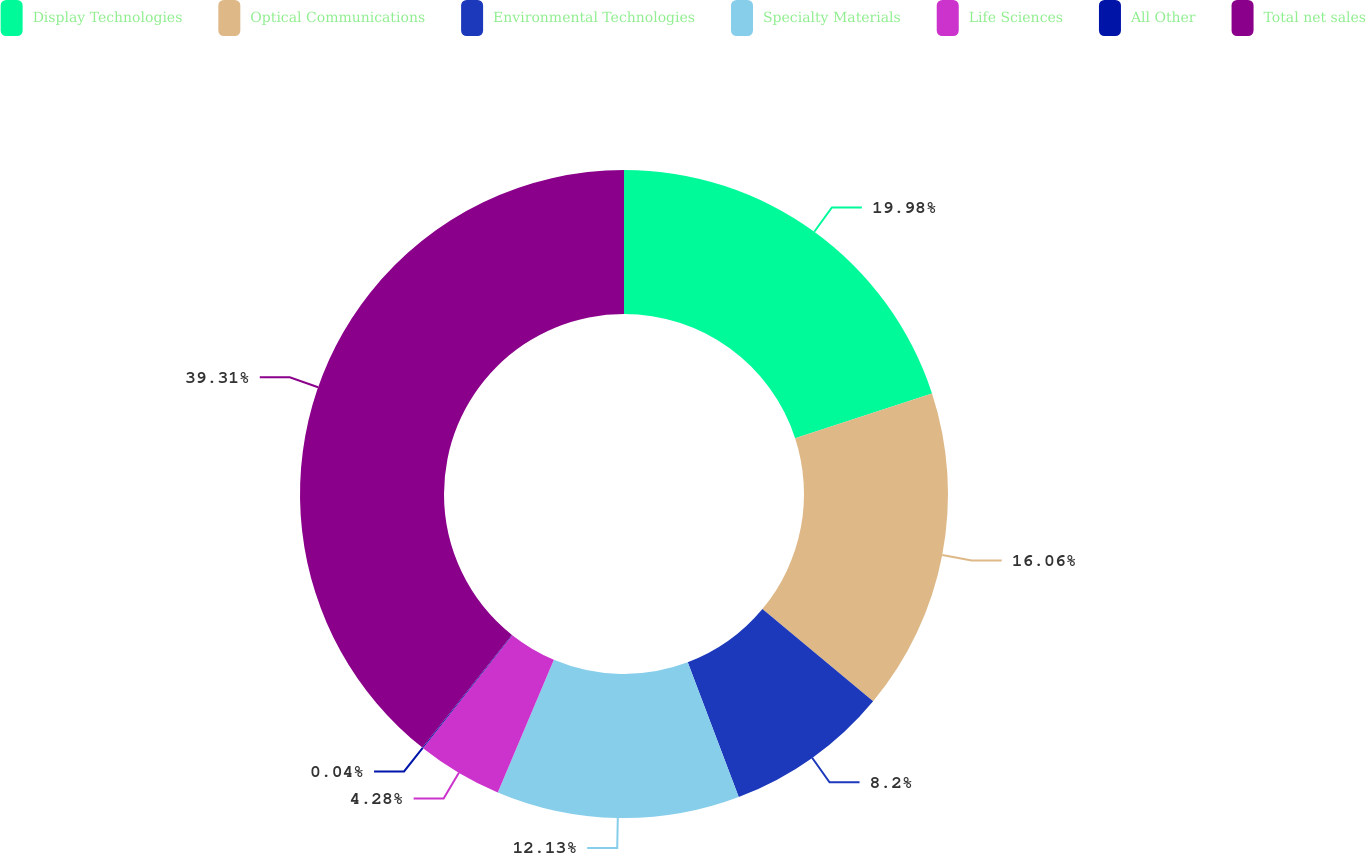<chart> <loc_0><loc_0><loc_500><loc_500><pie_chart><fcel>Display Technologies<fcel>Optical Communications<fcel>Environmental Technologies<fcel>Specialty Materials<fcel>Life Sciences<fcel>All Other<fcel>Total net sales<nl><fcel>19.98%<fcel>16.06%<fcel>8.2%<fcel>12.13%<fcel>4.28%<fcel>0.04%<fcel>39.31%<nl></chart> 